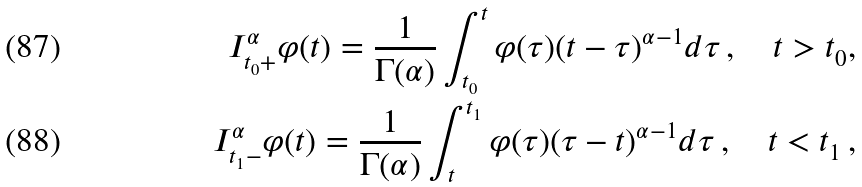<formula> <loc_0><loc_0><loc_500><loc_500>I ^ { \alpha } _ { t _ { 0 } + } \varphi ( t ) = \frac { 1 } { \Gamma ( \alpha ) } \int _ { t _ { 0 } } ^ { t } \varphi ( \tau ) ( t - \tau ) ^ { \alpha - 1 } d \tau \, , \quad t > t _ { 0 } , \\ I ^ { \alpha } _ { t _ { 1 } - } \varphi ( t ) = \frac { 1 } { \Gamma ( \alpha ) } \int _ { t } ^ { t _ { 1 } } \varphi ( \tau ) ( \tau - t ) ^ { \alpha - 1 } d \tau \, , \quad t < t _ { 1 } \, ,</formula> 